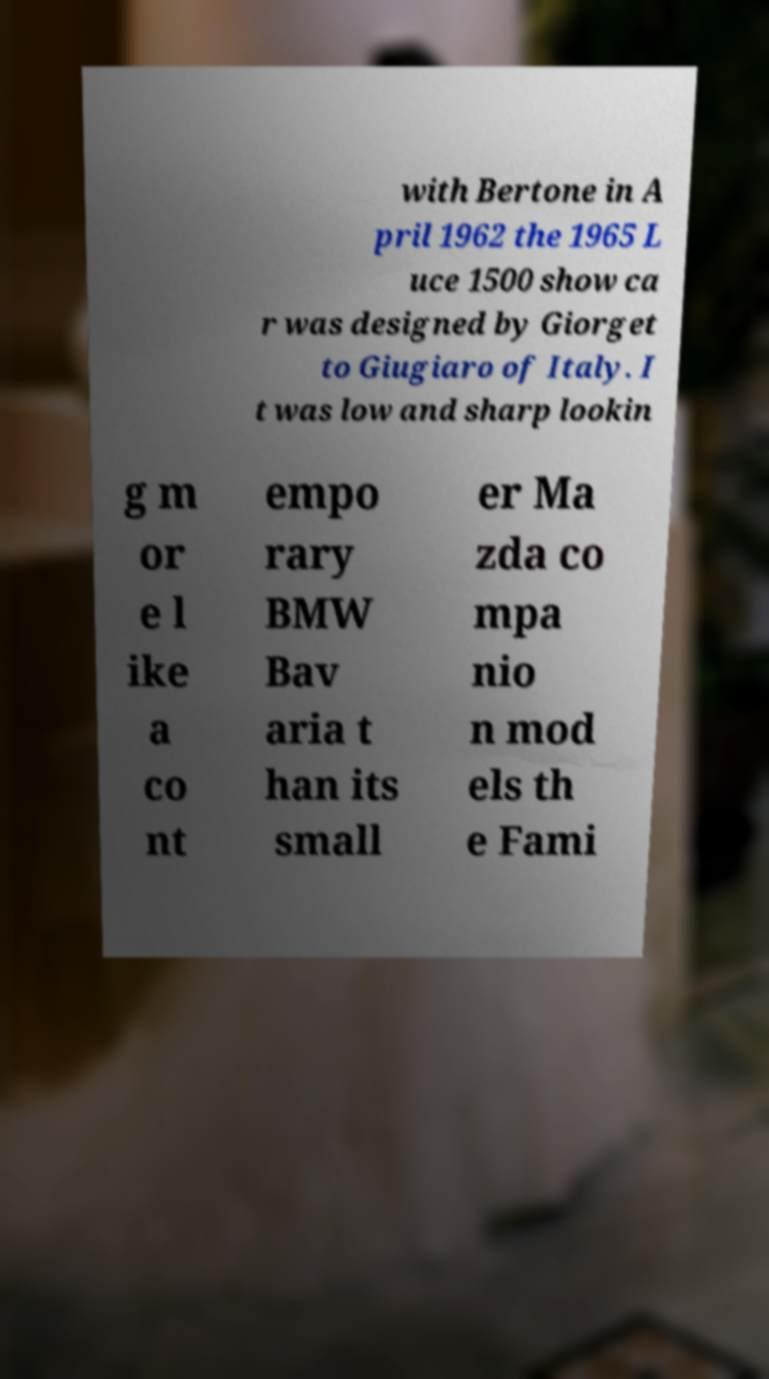What messages or text are displayed in this image? I need them in a readable, typed format. with Bertone in A pril 1962 the 1965 L uce 1500 show ca r was designed by Giorget to Giugiaro of Italy. I t was low and sharp lookin g m or e l ike a co nt empo rary BMW Bav aria t han its small er Ma zda co mpa nio n mod els th e Fami 